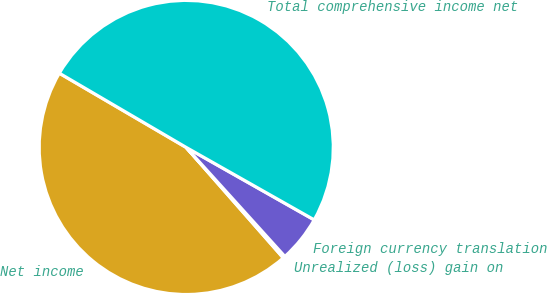<chart> <loc_0><loc_0><loc_500><loc_500><pie_chart><fcel>Net income<fcel>Unrealized (loss) gain on<fcel>Foreign currency translation<fcel>Total comprehensive income net<nl><fcel>44.9%<fcel>0.23%<fcel>5.1%<fcel>49.77%<nl></chart> 